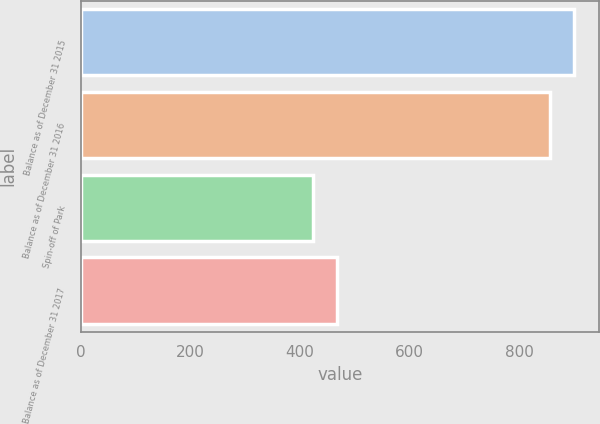<chart> <loc_0><loc_0><loc_500><loc_500><bar_chart><fcel>Balance as of December 31 2015<fcel>Balance as of December 31 2016<fcel>Spin-off of Park<fcel>Balance as of December 31 2017<nl><fcel>900.2<fcel>856<fcel>423<fcel>467.2<nl></chart> 